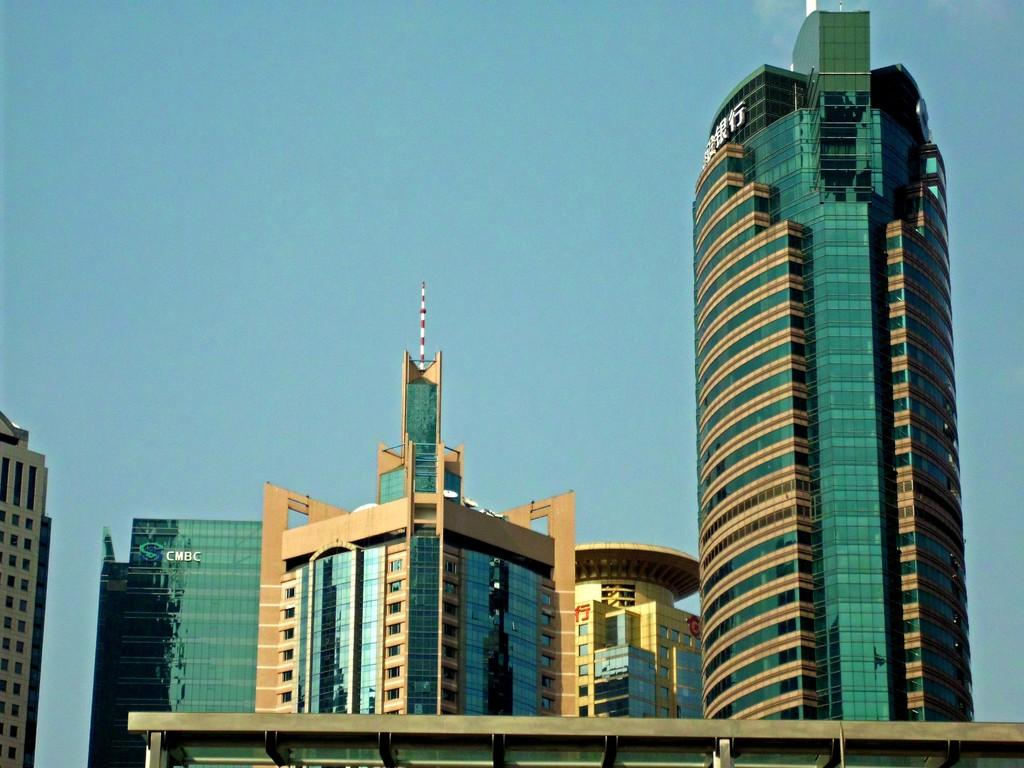What type of buildings can be seen in the image? There are tall buildings with glass in the image. What can be seen in the background of the image? The sky is visible in the image. How is the rice being cooked in the image? There is no rice present in the image; it only features tall buildings with glass and the sky. 